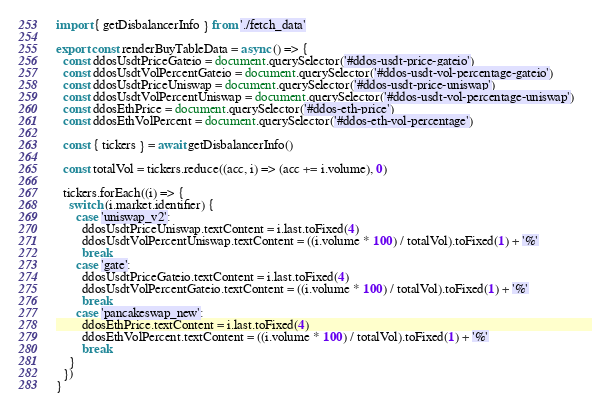<code> <loc_0><loc_0><loc_500><loc_500><_JavaScript_>import { getDisbalancerInfo } from './fetch_data'

export const renderBuyTableData = async () => {
  const ddosUsdtPriceGateio = document.querySelector('#ddos-usdt-price-gateio')
  const ddosUsdtVolPercentGateio = document.querySelector('#ddos-usdt-vol-percentage-gateio')
  const ddosUsdtPriceUniswap = document.querySelector('#ddos-usdt-price-uniswap')
  const ddosUsdtVolPercentUniswap = document.querySelector('#ddos-usdt-vol-percentage-uniswap')
  const ddosEthPrice = document.querySelector('#ddos-eth-price')
  const ddosEthVolPercent = document.querySelector('#ddos-eth-vol-percentage')

  const { tickers } = await getDisbalancerInfo()

  const totalVol = tickers.reduce((acc, i) => (acc += i.volume), 0)

  tickers.forEach((i) => {
    switch (i.market.identifier) {
      case 'uniswap_v2':
        ddosUsdtPriceUniswap.textContent = i.last.toFixed(4)
        ddosUsdtVolPercentUniswap.textContent = ((i.volume * 100) / totalVol).toFixed(1) + '%'
        break
      case 'gate':
        ddosUsdtPriceGateio.textContent = i.last.toFixed(4)
        ddosUsdtVolPercentGateio.textContent = ((i.volume * 100) / totalVol).toFixed(1) + '%'
        break
      case 'pancakeswap_new':
        ddosEthPrice.textContent = i.last.toFixed(4)
        ddosEthVolPercent.textContent = ((i.volume * 100) / totalVol).toFixed(1) + '%'
        break
    }
  })
}
</code> 